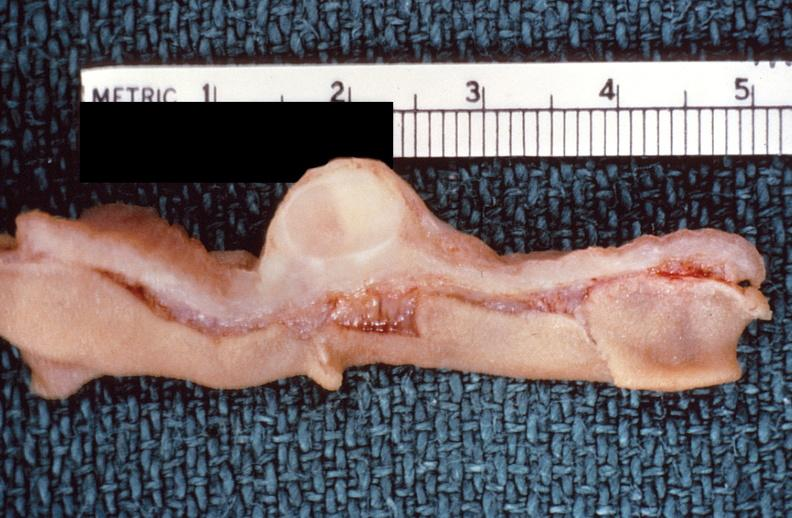does this image show intestine, leiomyoma?
Answer the question using a single word or phrase. Yes 